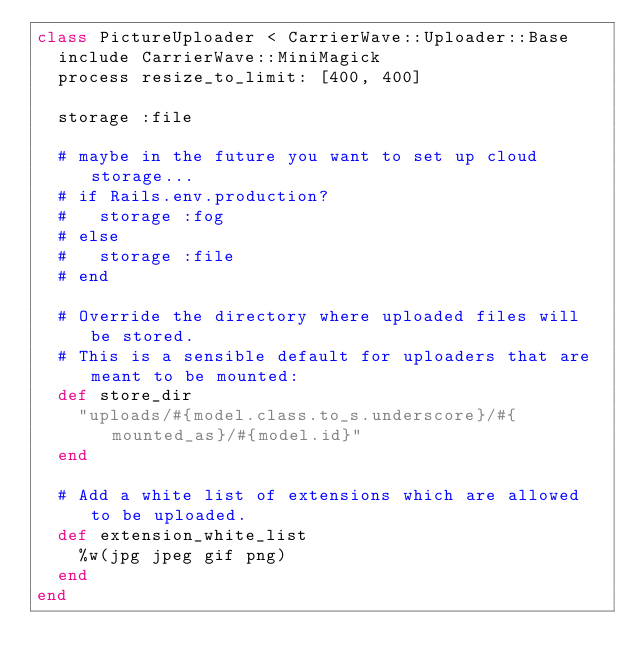Convert code to text. <code><loc_0><loc_0><loc_500><loc_500><_Ruby_>class PictureUploader < CarrierWave::Uploader::Base
  include CarrierWave::MiniMagick
  process resize_to_limit: [400, 400]

  storage :file

  # maybe in the future you want to set up cloud storage...
  # if Rails.env.production?
  #   storage :fog
  # else
  #   storage :file
  # end

  # Override the directory where uploaded files will be stored.
  # This is a sensible default for uploaders that are meant to be mounted:
  def store_dir
    "uploads/#{model.class.to_s.underscore}/#{mounted_as}/#{model.id}"
  end

  # Add a white list of extensions which are allowed to be uploaded.
  def extension_white_list
    %w(jpg jpeg gif png)
  end
end
</code> 